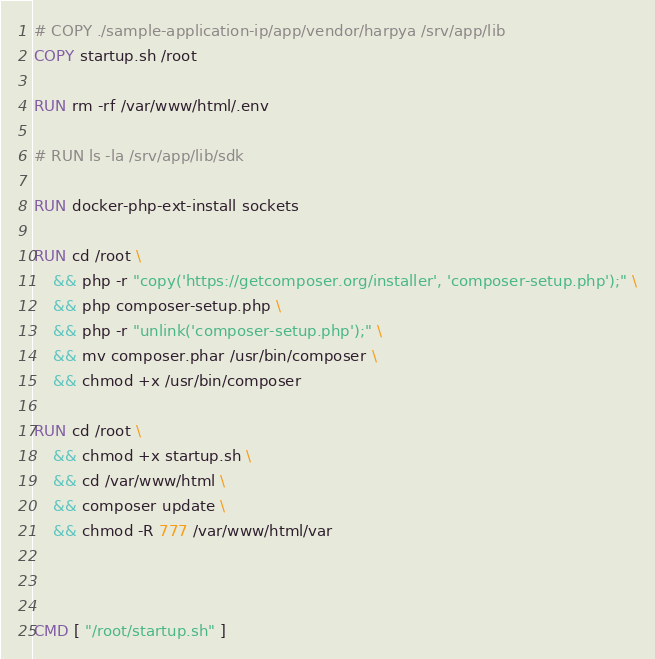Convert code to text. <code><loc_0><loc_0><loc_500><loc_500><_Dockerfile_># COPY ./sample-application-ip/app/vendor/harpya /srv/app/lib
COPY startup.sh /root

RUN rm -rf /var/www/html/.env

# RUN ls -la /srv/app/lib/sdk

RUN docker-php-ext-install sockets

RUN cd /root \
    && php -r "copy('https://getcomposer.org/installer', 'composer-setup.php');" \
    && php composer-setup.php \
    && php -r "unlink('composer-setup.php');" \
    && mv composer.phar /usr/bin/composer \ 
    && chmod +x /usr/bin/composer

RUN cd /root \
    && chmod +x startup.sh \
    && cd /var/www/html \
    && composer update \ 
    && chmod -R 777 /var/www/html/var



CMD [ "/root/startup.sh" ]</code> 